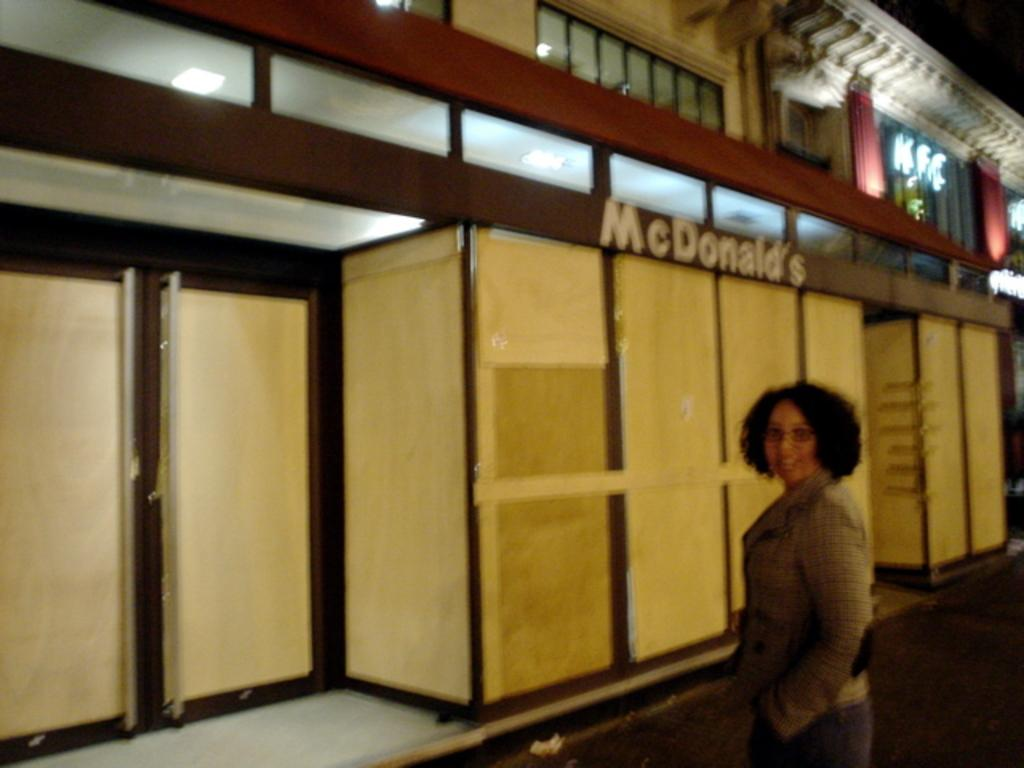Who is present in the image? There is a woman in the image. What is the woman wearing on her face? The woman is wearing spectacles. What can be seen in the background of the image? There is a building, boards, lights, and a door in the background of the image. What type of cannon can be seen in the image? There is no cannon present in the image. Is the woman riding a railway in the image? There is no railway or indication of any transportation in the image. 